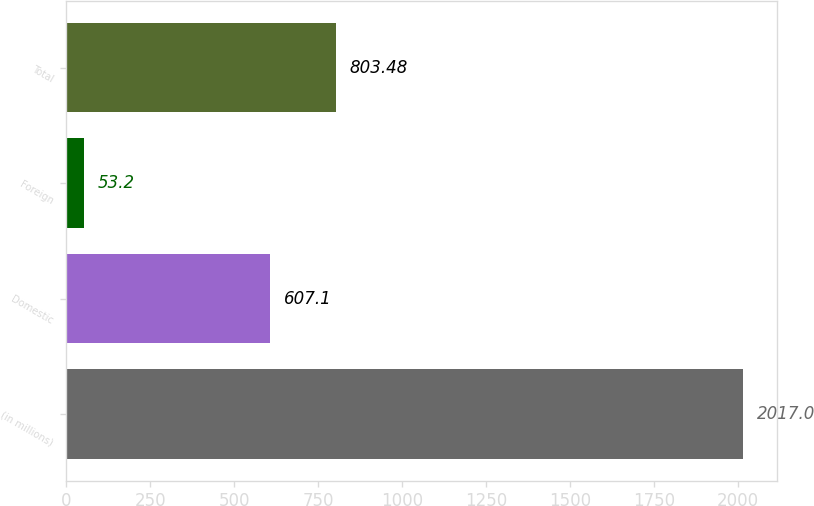Convert chart to OTSL. <chart><loc_0><loc_0><loc_500><loc_500><bar_chart><fcel>(in millions)<fcel>Domestic<fcel>Foreign<fcel>Total<nl><fcel>2017<fcel>607.1<fcel>53.2<fcel>803.48<nl></chart> 